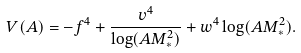Convert formula to latex. <formula><loc_0><loc_0><loc_500><loc_500>V ( A ) = - f ^ { 4 } + \frac { v ^ { 4 } } { \log ( A M _ { * } ^ { 2 } ) } + w ^ { 4 } \log ( A M _ { * } ^ { 2 } ) .</formula> 